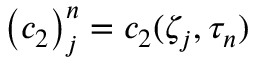Convert formula to latex. <formula><loc_0><loc_0><loc_500><loc_500>{ \left ( c _ { 2 } \right ) } _ { j } ^ { n } = c _ { 2 } ( \zeta _ { j } , \tau _ { n } )</formula> 